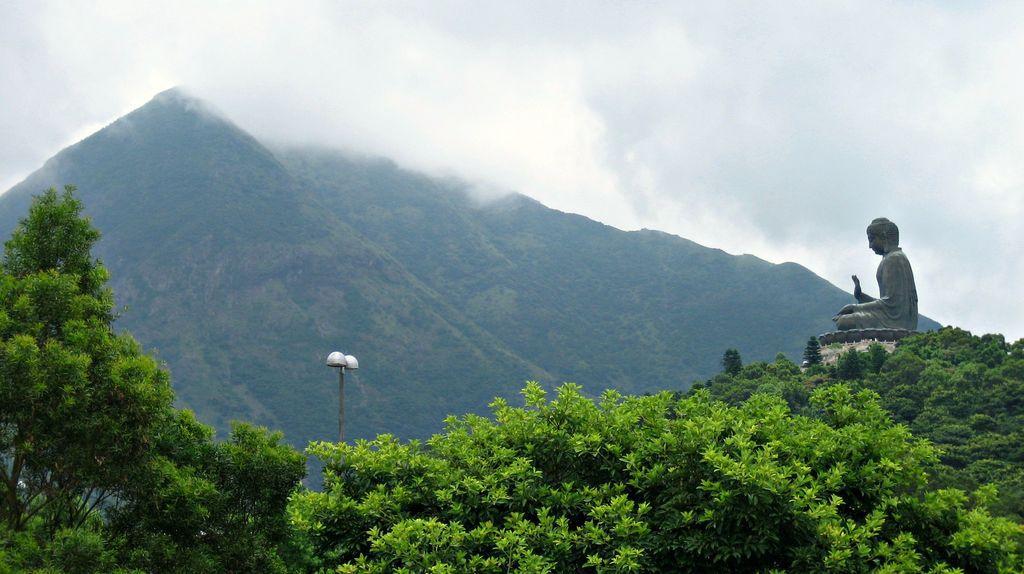In one or two sentences, can you explain what this image depicts? At the bottom of the image there are trees and also there is a statue. Behind the trees there is a pole with lamps. In the background there are hills. At the top of the image there is fog. 